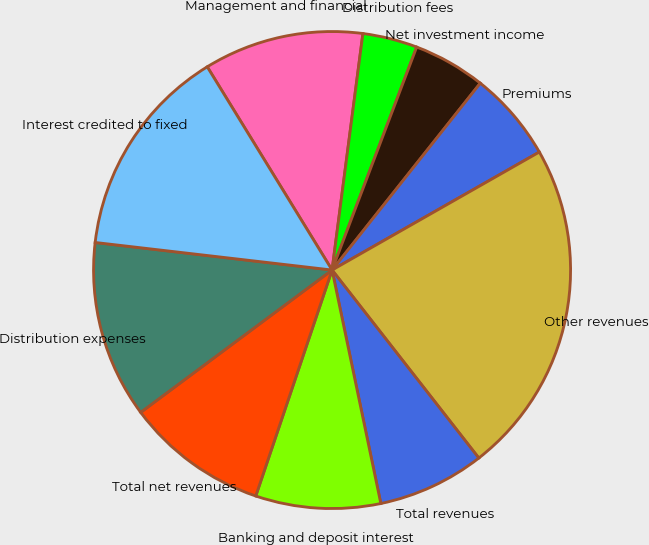Convert chart to OTSL. <chart><loc_0><loc_0><loc_500><loc_500><pie_chart><fcel>Management and financial<fcel>Distribution fees<fcel>Net investment income<fcel>Premiums<fcel>Other revenues<fcel>Total revenues<fcel>Banking and deposit interest<fcel>Total net revenues<fcel>Distribution expenses<fcel>Interest credited to fixed<nl><fcel>10.83%<fcel>3.71%<fcel>4.9%<fcel>6.09%<fcel>22.69%<fcel>7.27%<fcel>8.46%<fcel>9.64%<fcel>12.02%<fcel>14.39%<nl></chart> 